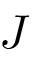Convert formula to latex. <formula><loc_0><loc_0><loc_500><loc_500>J</formula> 